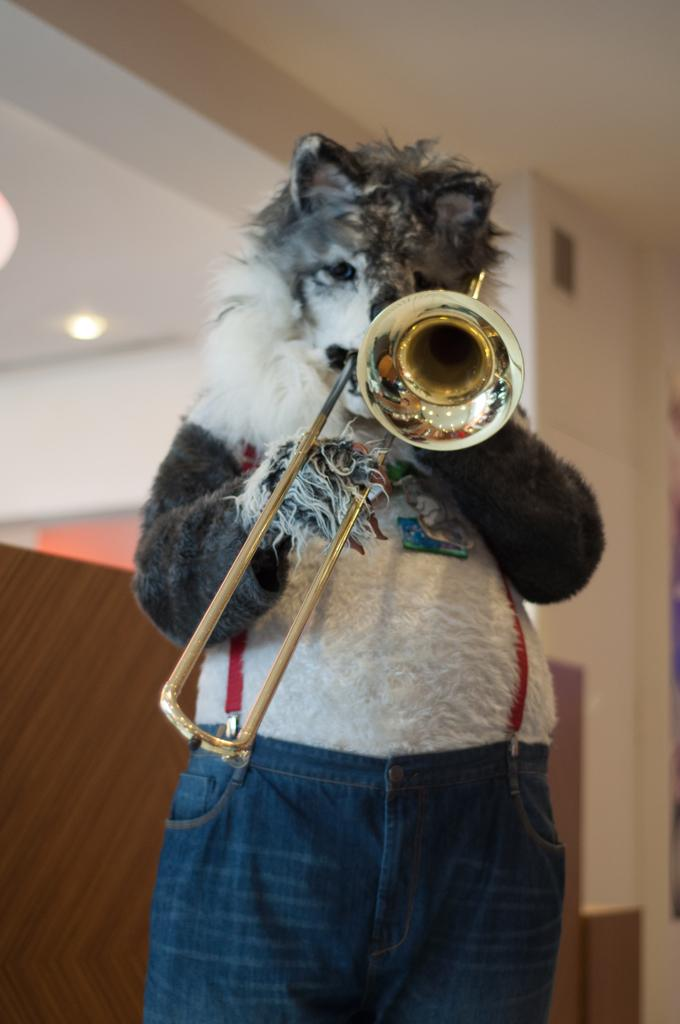What is the person in the image wearing? The person is wearing an animal costume. What is the person holding in the image? The person is holding a musical instrument. What color is the roof in the image? The roof in the image is white. What color is the wall in the image? The wall in the image is brown. What type of cream is being served in the image? There is no cream being served in the image; the focus is on the person wearing an animal costume and holding a musical instrument. 